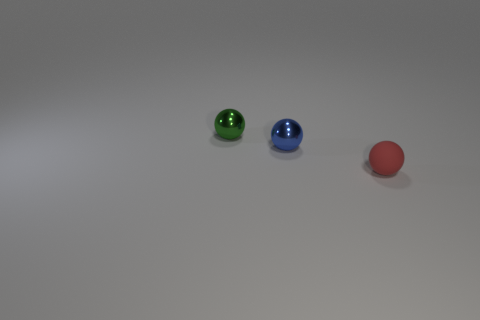There is a blue object that is the same shape as the small green thing; what material is it? The blue object appears to have a smooth, reflective surface similar to the small green object, suggesting that it might be made of a material like glass or polished stone, known for such visual properties. 